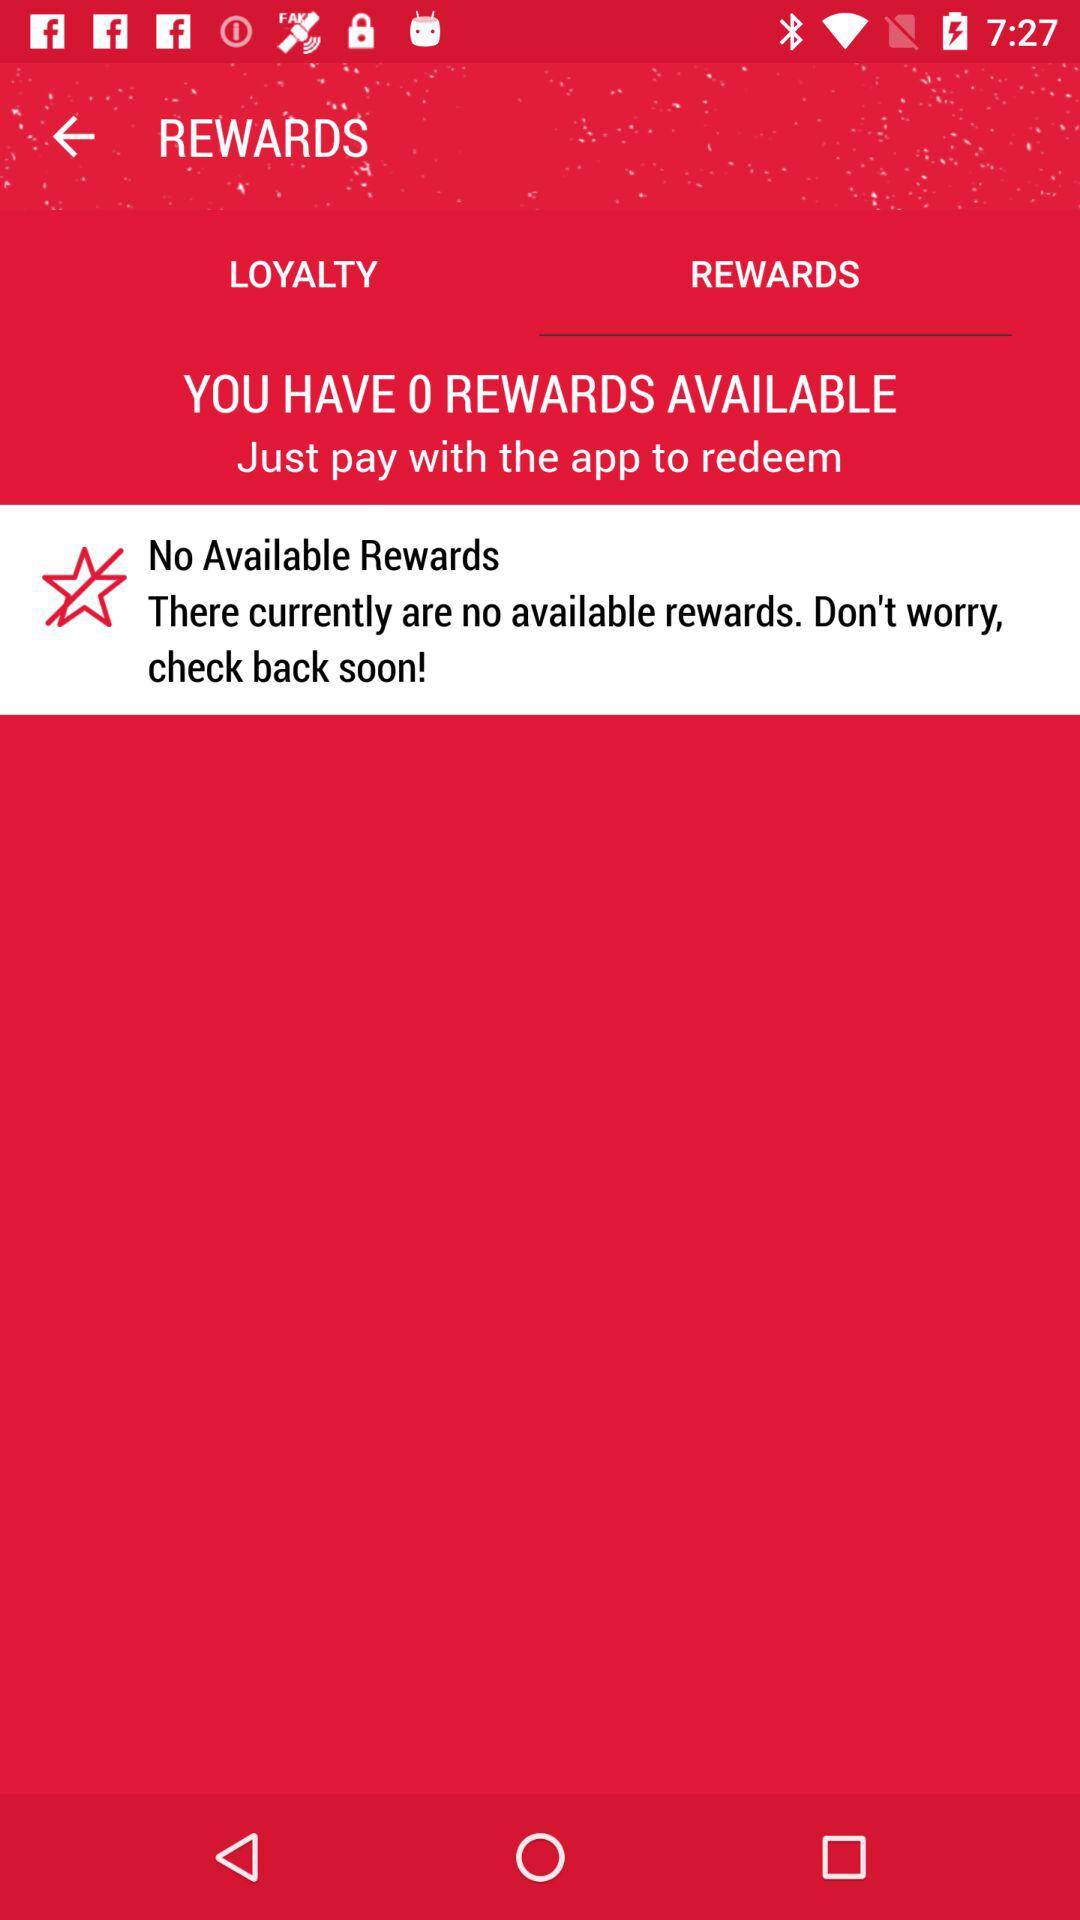How many rewards are available? There are no available rewards. 